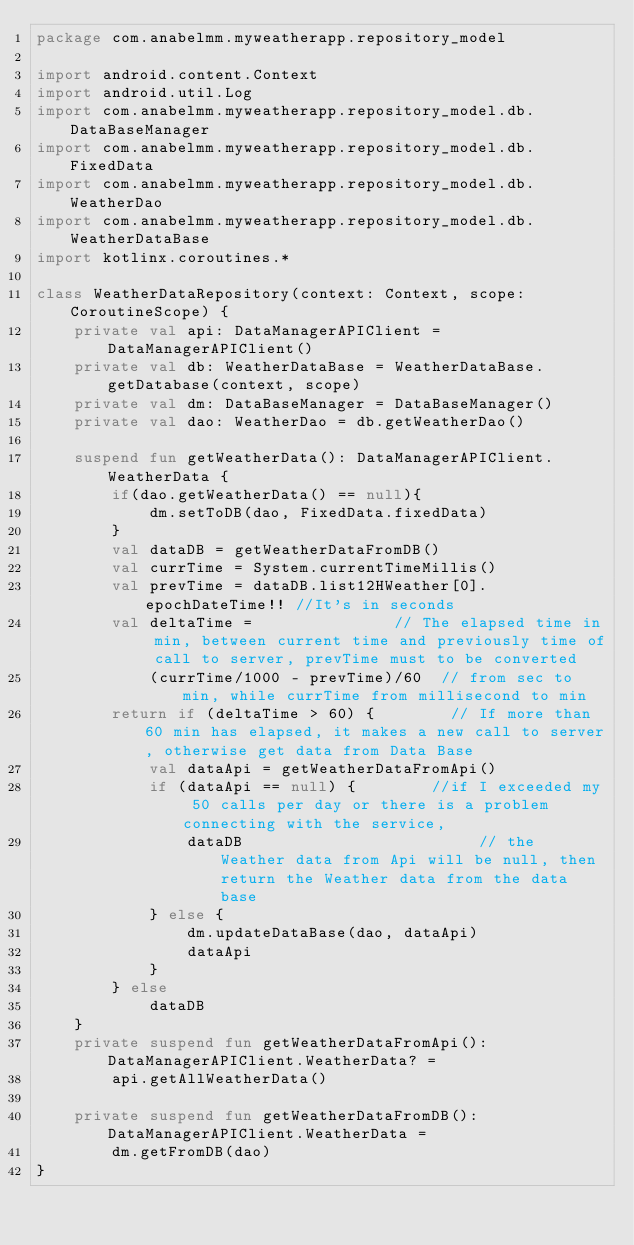Convert code to text. <code><loc_0><loc_0><loc_500><loc_500><_Kotlin_>package com.anabelmm.myweatherapp.repository_model

import android.content.Context
import android.util.Log
import com.anabelmm.myweatherapp.repository_model.db.DataBaseManager
import com.anabelmm.myweatherapp.repository_model.db.FixedData
import com.anabelmm.myweatherapp.repository_model.db.WeatherDao
import com.anabelmm.myweatherapp.repository_model.db.WeatherDataBase
import kotlinx.coroutines.*

class WeatherDataRepository(context: Context, scope: CoroutineScope) {
    private val api: DataManagerAPIClient = DataManagerAPIClient()
    private val db: WeatherDataBase = WeatherDataBase.getDatabase(context, scope)
    private val dm: DataBaseManager = DataBaseManager()
    private val dao: WeatherDao = db.getWeatherDao()

    suspend fun getWeatherData(): DataManagerAPIClient.WeatherData {
        if(dao.getWeatherData() == null){
            dm.setToDB(dao, FixedData.fixedData)
        }
        val dataDB = getWeatherDataFromDB()
        val currTime = System.currentTimeMillis()
        val prevTime = dataDB.list12HWeather[0].epochDateTime!! //It's in seconds
        val deltaTime =               // The elapsed time in min, between current time and previously time of call to server, prevTime must to be converted
            (currTime/1000 - prevTime)/60  // from sec to min, while currTime from millisecond to min
        return if (deltaTime > 60) {        // If more than 60 min has elapsed, it makes a new call to server, otherwise get data from Data Base
            val dataApi = getWeatherDataFromApi()
            if (dataApi == null) {        //if I exceeded my 50 calls per day or there is a problem connecting with the service,
                dataDB                         // the Weather data from Api will be null, then return the Weather data from the data base
            } else {
                dm.updateDataBase(dao, dataApi)
                dataApi
            }
        } else
            dataDB
    }
    private suspend fun getWeatherDataFromApi(): DataManagerAPIClient.WeatherData? =
        api.getAllWeatherData()

    private suspend fun getWeatherDataFromDB(): DataManagerAPIClient.WeatherData =
        dm.getFromDB(dao)
}</code> 